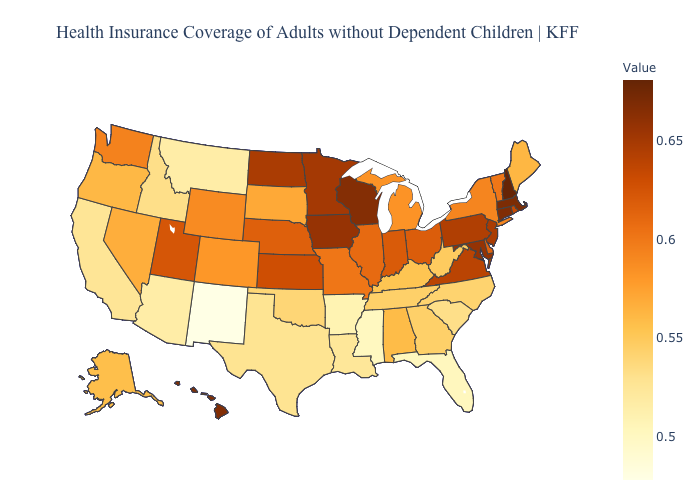Which states have the highest value in the USA?
Answer briefly. New Hampshire. Does New Mexico have the lowest value in the USA?
Keep it brief. Yes. Among the states that border South Dakota , does Montana have the lowest value?
Answer briefly. Yes. Does the map have missing data?
Be succinct. No. Does Nebraska have a higher value than New Jersey?
Concise answer only. No. Which states hav the highest value in the MidWest?
Quick response, please. Wisconsin. Among the states that border Pennsylvania , does Ohio have the highest value?
Concise answer only. No. Does Rhode Island have a lower value than South Carolina?
Keep it brief. No. 